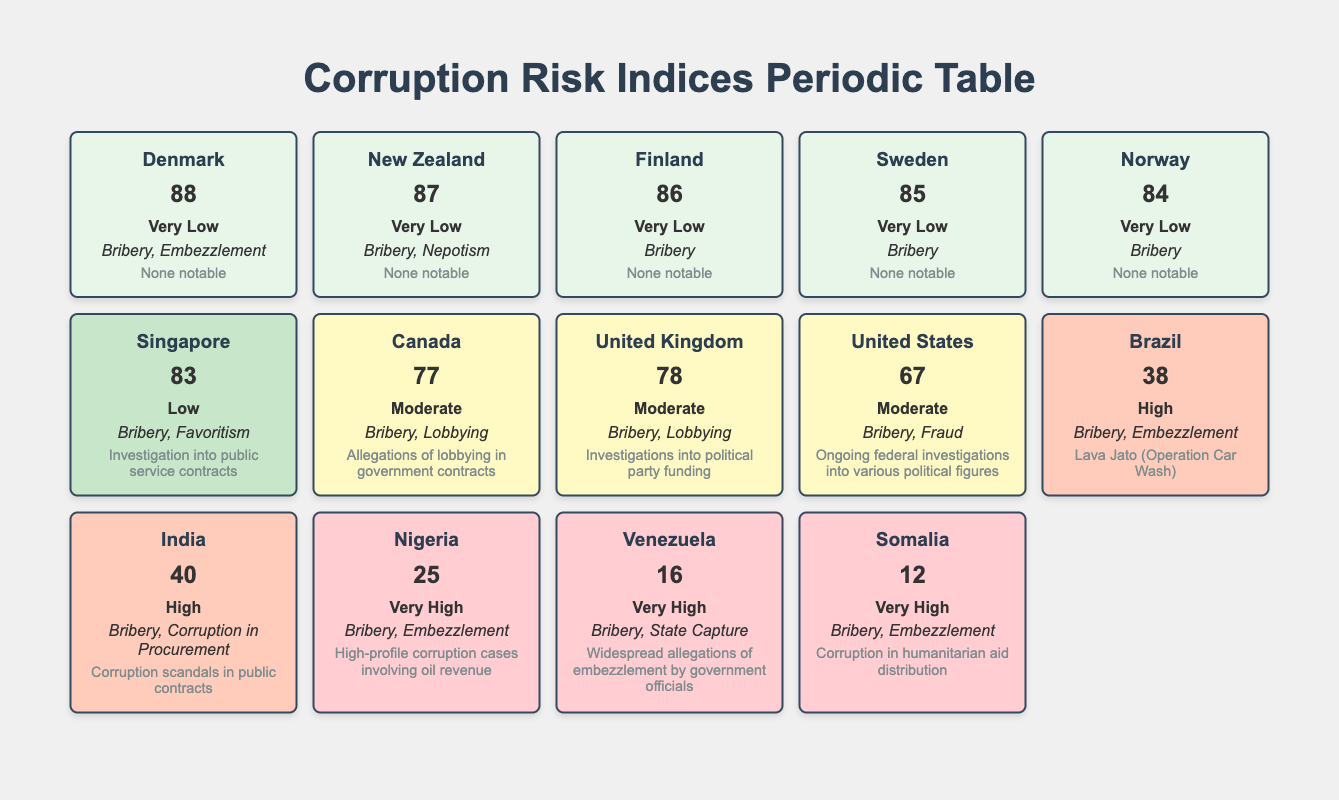What is the CPI score for Singapore? The table lists Singapore under the "Corruption Risk Indices" section with a CPI score of 83.
Answer: 83 Which country has the highest CPI score? Looking at the table, Denmark has the highest CPI score of 88.
Answer: Denmark What are the recent incidents reported for Nigeria? The table states that Nigeria has recent incidents of "High-profile corruption cases involving oil revenue."
Answer: High-profile corruption cases involving oil revenue How many countries have a "Very Low" risk grade? The table shows 5 countries listed under the "Very Low" risk grade: Denmark, New Zealand, Finland, Sweden, and Norway.
Answer: 5 Which country has a lower CPI score, India or Brazil? Comparing the CPI scores, India has a score of 40 while Brazil has a score of 38. Since 40 is greater than 38, India has a higher score. Thus, Brazil has the lower score.
Answer: Brazil Is there any country with a risk grade of "Moderate" that has not reported recent incidents? Reviewing the table, both Canada and the United States have a "Moderate" risk grade but both have reported recent incidents. Therefore, no country meets the criteria.
Answer: No What is the average CPI score of countries with a "Very High" risk grade? The CPI scores for countries with a "Very High" grade are: Nigeria (25), Venezuela (16), and Somalia (12). Adding these scores gives 25 + 16 + 12 = 53. There are 3 countries, so the average is 53/3 = 17.67.
Answer: 17.67 How many different types of corruption are noted for the United Kingdom? The table indicates that the United Kingdom has "Bribery" and "Lobbying" as its corruption types, counting them gives a total of 2 types.
Answer: 2 Is the recent incident for Singapore categorized under bribery? The table states that Singapore’s recent incident is "Investigation into public service contracts," which does not explicitly categorize it under bribery. Therefore, the statement is false.
Answer: No 